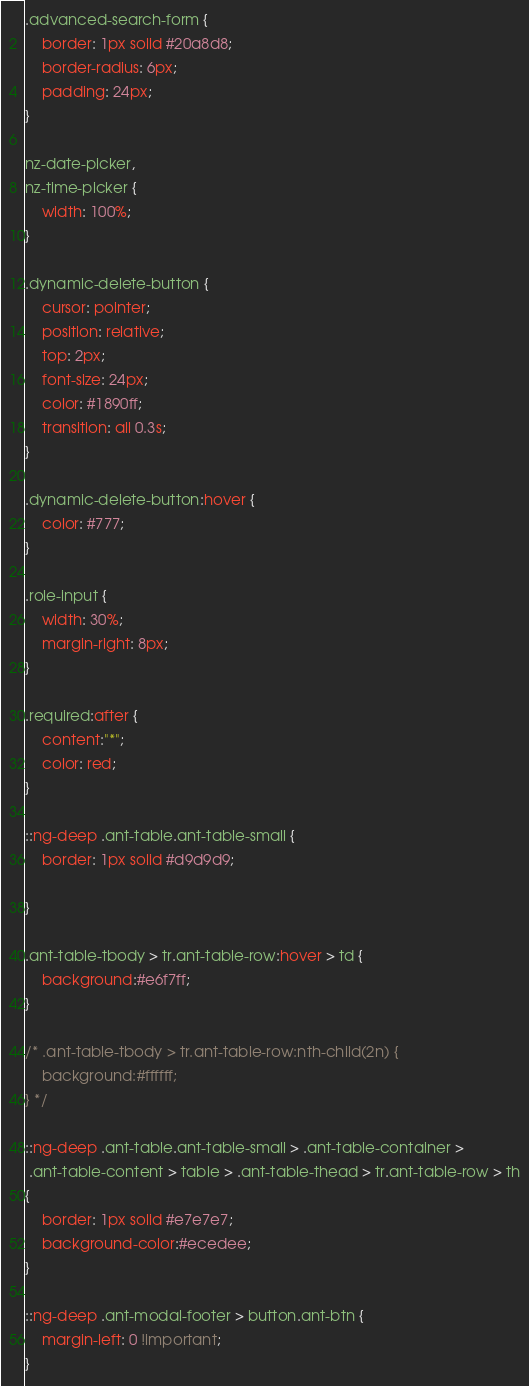<code> <loc_0><loc_0><loc_500><loc_500><_CSS_>.advanced-search-form {
    border: 1px solid #20a8d8;
    border-radius: 6px; 
    padding: 24px;
}

nz-date-picker,
nz-time-picker {
    width: 100%;
}

.dynamic-delete-button {
    cursor: pointer;
    position: relative;
    top: 2px;
    font-size: 24px;
    color: #1890ff;
    transition: all 0.3s;
}

.dynamic-delete-button:hover {
    color: #777;
}

.role-input {
    width: 30%;
    margin-right: 8px;
}

.required:after {
    content:"*";
    color: red;
}

::ng-deep .ant-table.ant-table-small {
    border: 1px solid #d9d9d9;
    
}

.ant-table-tbody > tr.ant-table-row:hover > td {
    background:#e6f7ff;
}

/* .ant-table-tbody > tr.ant-table-row:nth-child(2n) {
    background:#ffffff;
} */

::ng-deep .ant-table.ant-table-small > .ant-table-container >
 .ant-table-content > table > .ant-table-thead > tr.ant-table-row > th
{ 
    border: 1px solid #e7e7e7;
    background-color:#ecedee;
}

::ng-deep .ant-modal-footer > button.ant-btn {
    margin-left: 0 !important;
}





</code> 